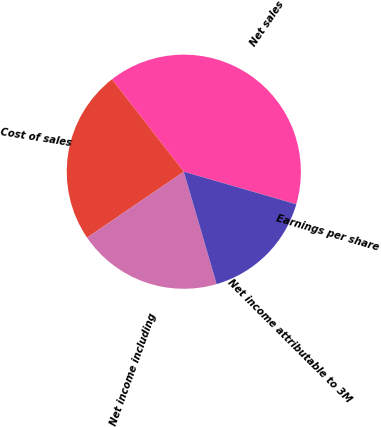<chart> <loc_0><loc_0><loc_500><loc_500><pie_chart><fcel>Net sales<fcel>Cost of sales<fcel>Net income including<fcel>Net income attributable to 3M<fcel>Earnings per share<nl><fcel>39.99%<fcel>24.0%<fcel>20.0%<fcel>16.0%<fcel>0.01%<nl></chart> 